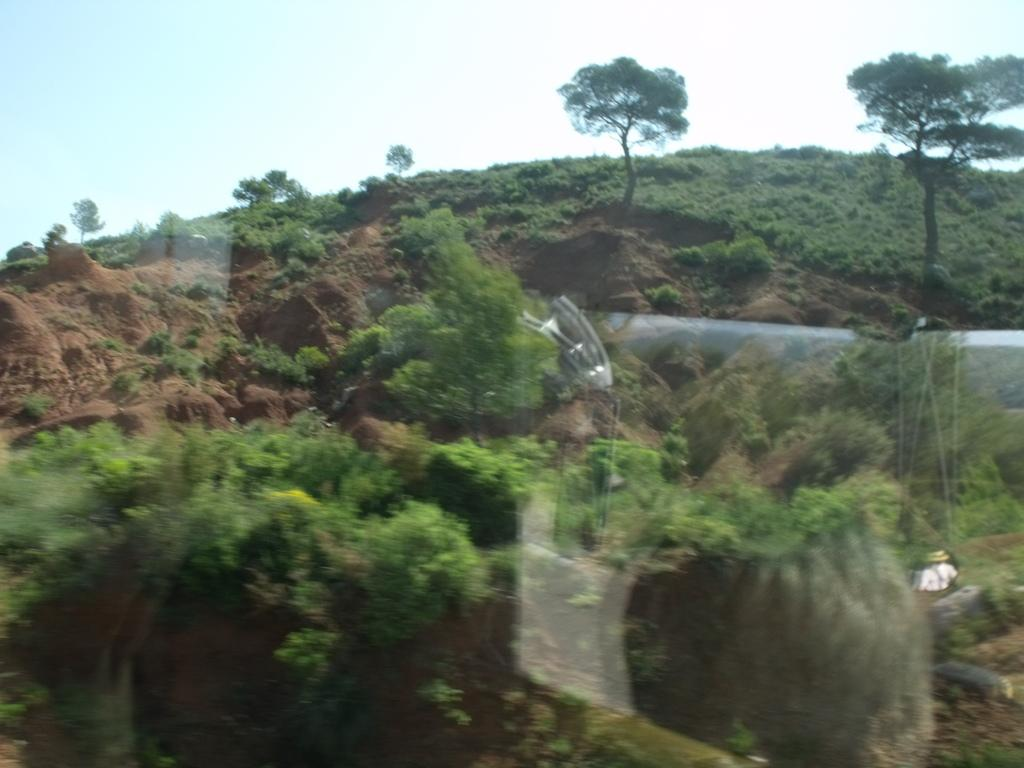What type of vegetation is present in the image? There are trees and plants in the image. What type of structure can be seen in the image? There is a wall in the image. What part of the natural environment is visible in the image? The sky is visible in the background of the image. What type of distribution system is present in the image? There is no distribution system present in the image; it features trees, plants, a wall, and the sky. What theory is being demonstrated in the image? There is no theory being demonstrated in the image; it is a simple depiction of trees, plants, a wall, and the sky. 